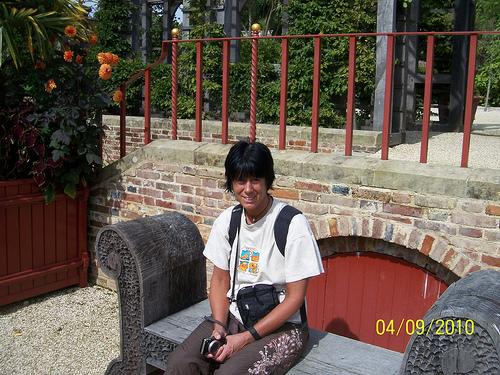Identify the presence of any outdoor furniture in the image. There is a gray outdoor bench and a large cement bench. Identify the color and type of fence present in the image. The fence is pink and made from metal. Explain the significance of the black straps in the image. The black straps are part of a backpack, specifically the shoulder strap of a backpack, and there are two of them. What is the state of the woman's expression and an accessory she is wearing? The woman is smiling and has a necklace around her neck. What object in the image has a relation to a wall and what is its color? A clay brick built into a wall has a relation to a wall and its color is not specified. Count the number of flowers next to each other described in the image. There are 9 flowers next to each other. Describe the features of the person in the image and their actions. A woman with short dark hair is sitting on a bench, wearing a white shirt and smiling. State the interaction between the woman and the bench in the image. The woman is sitting on the bench. What type of flowers are associated with a color in the image? A bunch of orange flowers and an orange flower. Look for a blue skateboard leaning against the bench. Asking the viewer to look for a blue skateboard implies that there is one in the image, even though the given information doesn't mention it. It creates false expectations of seeing a skateboard in the image. A cat is curiously observing the flowers from a distance. Isn't that cute? The statement introduces a non-existent cat into the scene and comments on it being cute. This makes the reader believe that there is indeed a cat in the image and can mislead them into looking for it. What color do you think the balloons in the tree are? By questioning the color of the non-existent balloons, the reader is tricked into believing that there are balloons present in the image. It confuses the reader as they search for something that doesn't exist. The pigeon perched on the wooden planter is truly a sight to behold. No, it's not mentioned in the image. Can you spot the yellow umbrella near the flowers in the image? There is no mention of a yellow umbrella in the given information, and this instruction makes the reader search for a non-existent object in the image by posing a seemingly innocent question. 